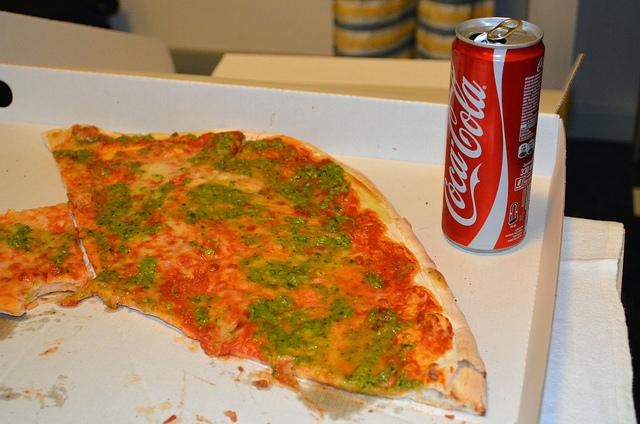What is green on this pizza?
Keep it brief. Pesto. What is the name of the drink?
Answer briefly. Coca cola. How many glasses of beer is there?
Give a very brief answer. 0. Is this a homemade pizza?
Be succinct. No. What are they drinking?
Concise answer only. Coca cola. Does the pizza have vegetables or meat?
Be succinct. Vegetables. What are the people drinking?
Keep it brief. Coca cola. How many slices of pizza are shown?
Be succinct. 4. What kind of drink is on the table?
Answer briefly. Coca cola. 